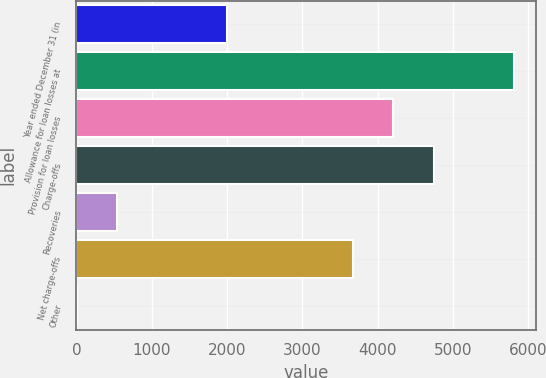Convert chart. <chart><loc_0><loc_0><loc_500><loc_500><bar_chart><fcel>Year ended December 31 (in<fcel>Allowance for loan losses at<fcel>Provision for loan losses<fcel>Charge-offs<fcel>Recoveries<fcel>Net charge-offs<fcel>Other<nl><fcel>2002<fcel>5814.8<fcel>4210.7<fcel>4745.4<fcel>537.7<fcel>3676<fcel>3<nl></chart> 